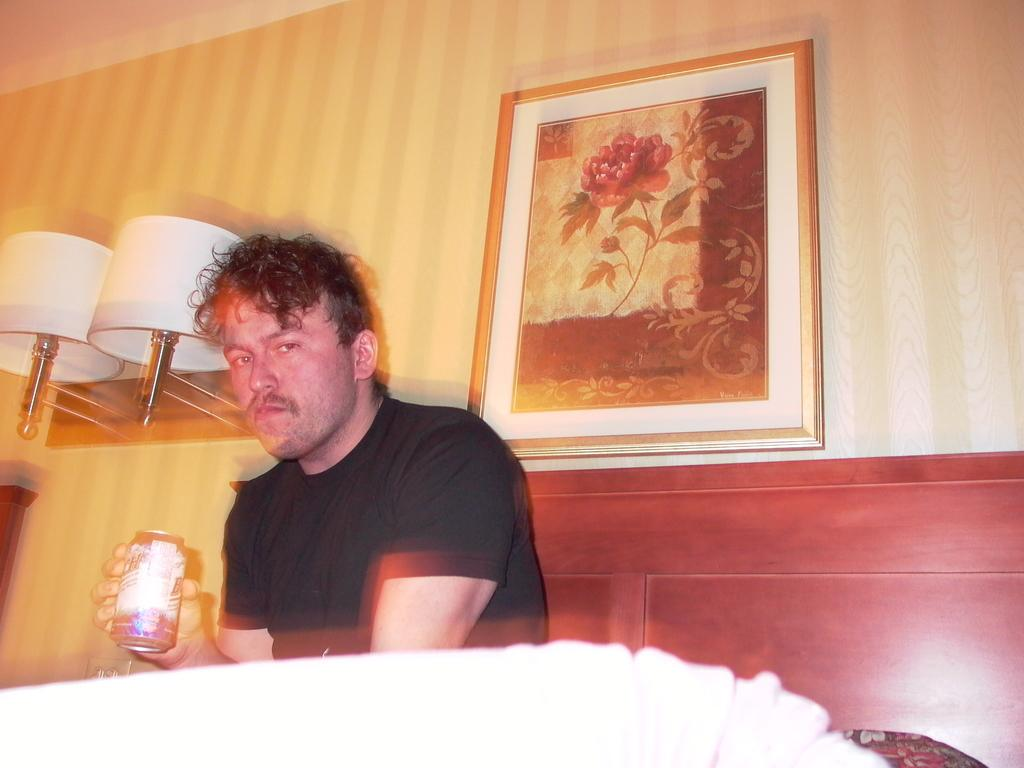What is the man in the image doing? The man is sitting on the bed. What is the man holding in the image? The man is holding a tin. What is covering the bed? There is a blanket on the bed. What type of lighting is present in the image? There are lamps in the image. What can be seen on the wall in the background? There is a frame attached to the wall in the background. What type of scarecrow is standing in the corner of the room in the image? There is no scarecrow present in the image. What type of liquid is being poured from the tin in the image? There is no liquid being poured in the image; the man is simply holding a tin. 